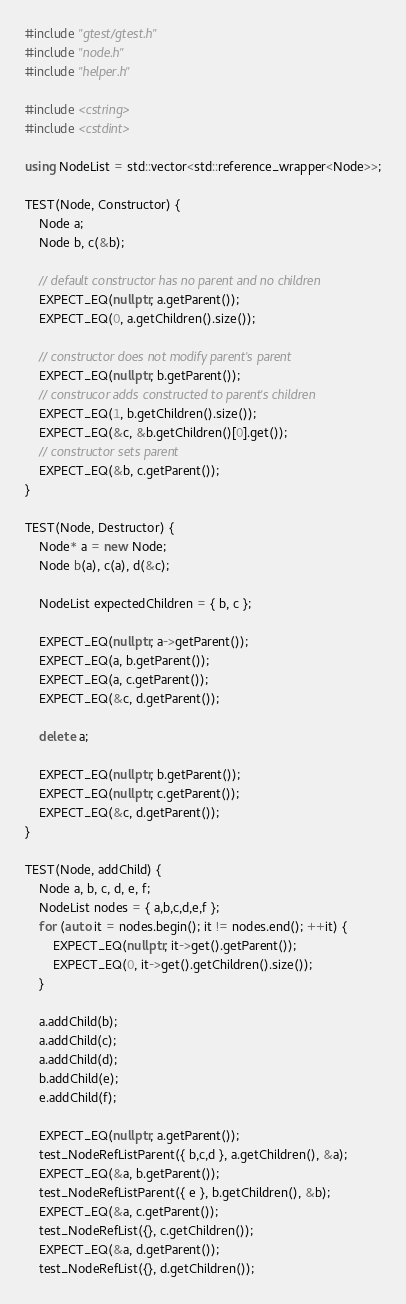<code> <loc_0><loc_0><loc_500><loc_500><_C++_>#include "gtest/gtest.h"
#include "node.h"
#include "helper.h"

#include <cstring>
#include <cstdint>

using NodeList = std::vector<std::reference_wrapper<Node>>;

TEST(Node, Constructor) {
	Node a;
	Node b, c(&b);

	// default constructor has no parent and no children
	EXPECT_EQ(nullptr, a.getParent());
	EXPECT_EQ(0, a.getChildren().size());

	// constructor does not modify parent's parent
	EXPECT_EQ(nullptr, b.getParent());
	// construcor adds constructed to parent's children
	EXPECT_EQ(1, b.getChildren().size());
	EXPECT_EQ(&c, &b.getChildren()[0].get());
	// constructor sets parent
	EXPECT_EQ(&b, c.getParent());
}

TEST(Node, Destructor) {
	Node* a = new Node;
	Node b(a), c(a), d(&c);

	NodeList expectedChildren = { b, c };

	EXPECT_EQ(nullptr, a->getParent());
	EXPECT_EQ(a, b.getParent());
	EXPECT_EQ(a, c.getParent());
	EXPECT_EQ(&c, d.getParent());

	delete a;

	EXPECT_EQ(nullptr, b.getParent());
	EXPECT_EQ(nullptr, c.getParent());
	EXPECT_EQ(&c, d.getParent());
}

TEST(Node, addChild) {
	Node a, b, c, d, e, f;
	NodeList nodes = { a,b,c,d,e,f };
	for (auto it = nodes.begin(); it != nodes.end(); ++it) {
		EXPECT_EQ(nullptr, it->get().getParent());
		EXPECT_EQ(0, it->get().getChildren().size());
	}

	a.addChild(b);
	a.addChild(c);
	a.addChild(d);
	b.addChild(e);
	e.addChild(f);

	EXPECT_EQ(nullptr, a.getParent());
	test_NodeRefListParent({ b,c,d }, a.getChildren(), &a);
	EXPECT_EQ(&a, b.getParent());
	test_NodeRefListParent({ e }, b.getChildren(), &b);
	EXPECT_EQ(&a, c.getParent());
	test_NodeRefList({}, c.getChildren());
	EXPECT_EQ(&a, d.getParent());
	test_NodeRefList({}, d.getChildren());</code> 